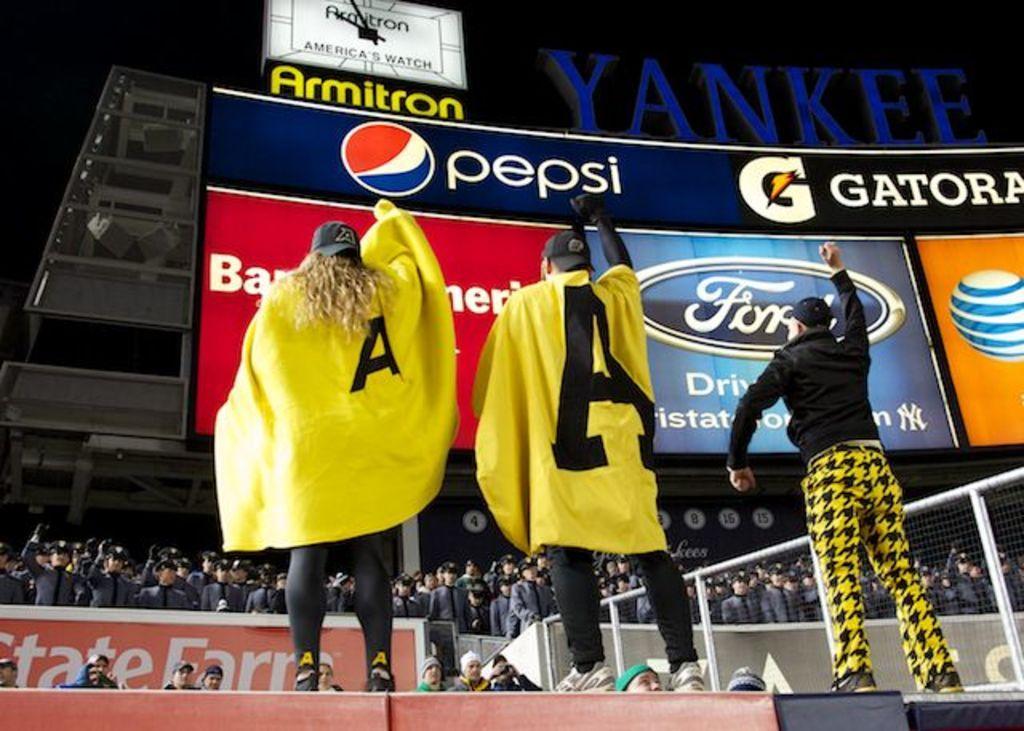How would you summarize this image in a sentence or two? In this image there are three people standing and raising their hands to the upwards, in front of them there is are so many people and there is a railing. In the background there is a banner with some text is hanging on the wall of the building and there is a clock. The background is dark. 